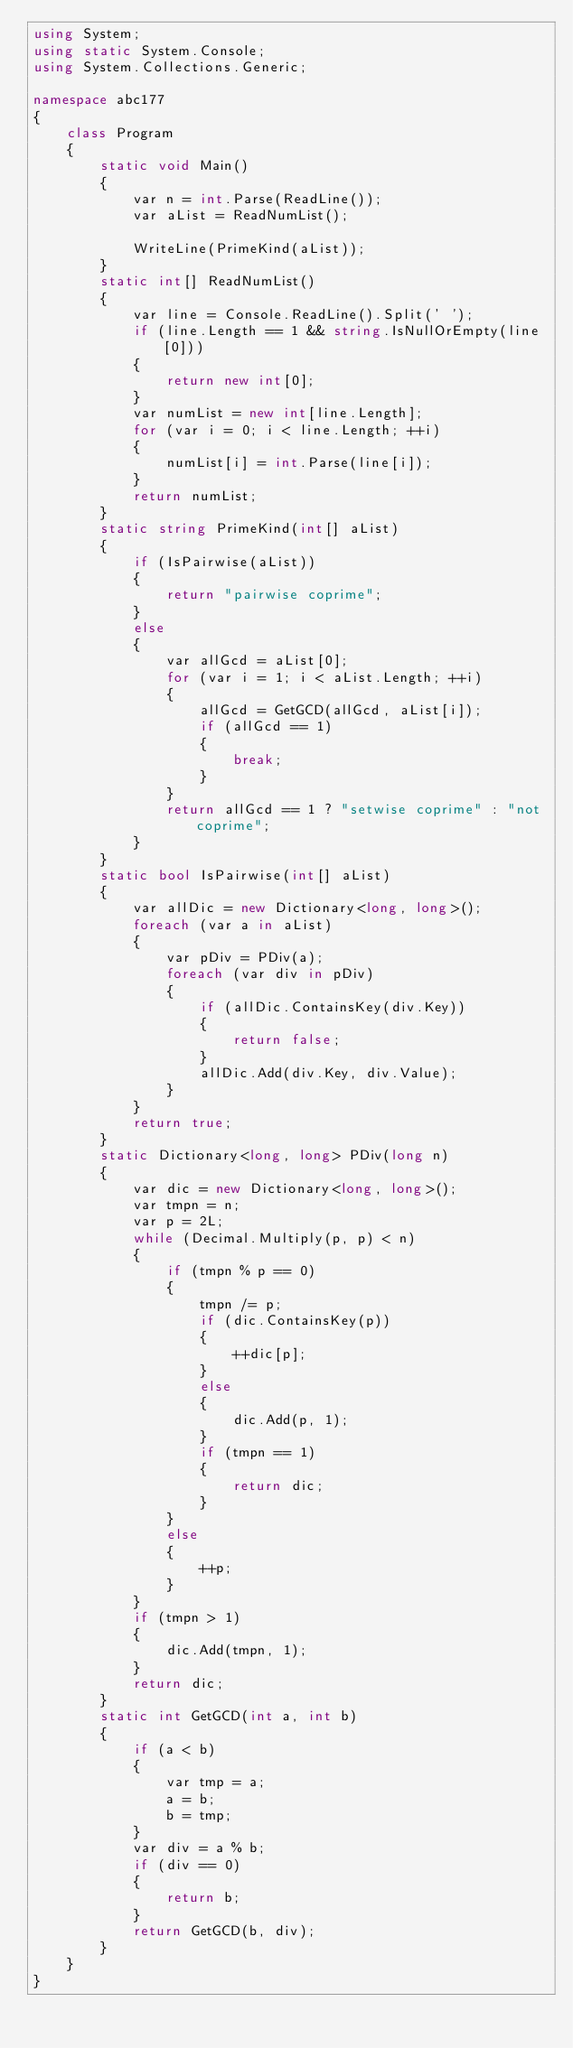Convert code to text. <code><loc_0><loc_0><loc_500><loc_500><_C#_>using System;
using static System.Console;
using System.Collections.Generic;

namespace abc177
{
    class Program
    {
        static void Main()
        {
            var n = int.Parse(ReadLine());
            var aList = ReadNumList();
 
            WriteLine(PrimeKind(aList));
        }
        static int[] ReadNumList()
        {
            var line = Console.ReadLine().Split(' ');
            if (line.Length == 1 && string.IsNullOrEmpty(line[0]))
            {
                return new int[0];
            }
            var numList = new int[line.Length];
            for (var i = 0; i < line.Length; ++i)
            {
                numList[i] = int.Parse(line[i]);
            }
            return numList;
        }
        static string PrimeKind(int[] aList)
        {
            if (IsPairwise(aList))
            {
                return "pairwise coprime";
            }
            else
            {
                var allGcd = aList[0];
                for (var i = 1; i < aList.Length; ++i)
                {
                    allGcd = GetGCD(allGcd, aList[i]);
                    if (allGcd == 1)
                    {
                        break;
                    }
                }
                return allGcd == 1 ? "setwise coprime" : "not coprime";
            }
        }
        static bool IsPairwise(int[] aList)
        {
            var allDic = new Dictionary<long, long>();
            foreach (var a in aList)
            {
                var pDiv = PDiv(a);
                foreach (var div in pDiv)
                {
                    if (allDic.ContainsKey(div.Key))
                    {
                        return false;
                    }
                    allDic.Add(div.Key, div.Value);
                }
            }
            return true;
        }
        static Dictionary<long, long> PDiv(long n)
        {
            var dic = new Dictionary<long, long>();
            var tmpn = n;
            var p = 2L;
            while (Decimal.Multiply(p, p) < n)
            {
                if (tmpn % p == 0)
                {
                    tmpn /= p;
                    if (dic.ContainsKey(p))
                    {
                        ++dic[p];
                    }
                    else
                    {
                        dic.Add(p, 1);
                    }
                    if (tmpn == 1)
                    {
                        return dic;
                    }
                }
                else
                {
                    ++p;
                }
            }
            if (tmpn > 1)
            {
                dic.Add(tmpn, 1);
            }
            return dic;
        }
        static int GetGCD(int a, int b)
        {
            if (a < b)
            {
                var tmp = a;
                a = b;
                b = tmp;
            }
            var div = a % b;
            if (div == 0)
            {
                return b;
            }
            return GetGCD(b, div);
        }
    }
}
</code> 